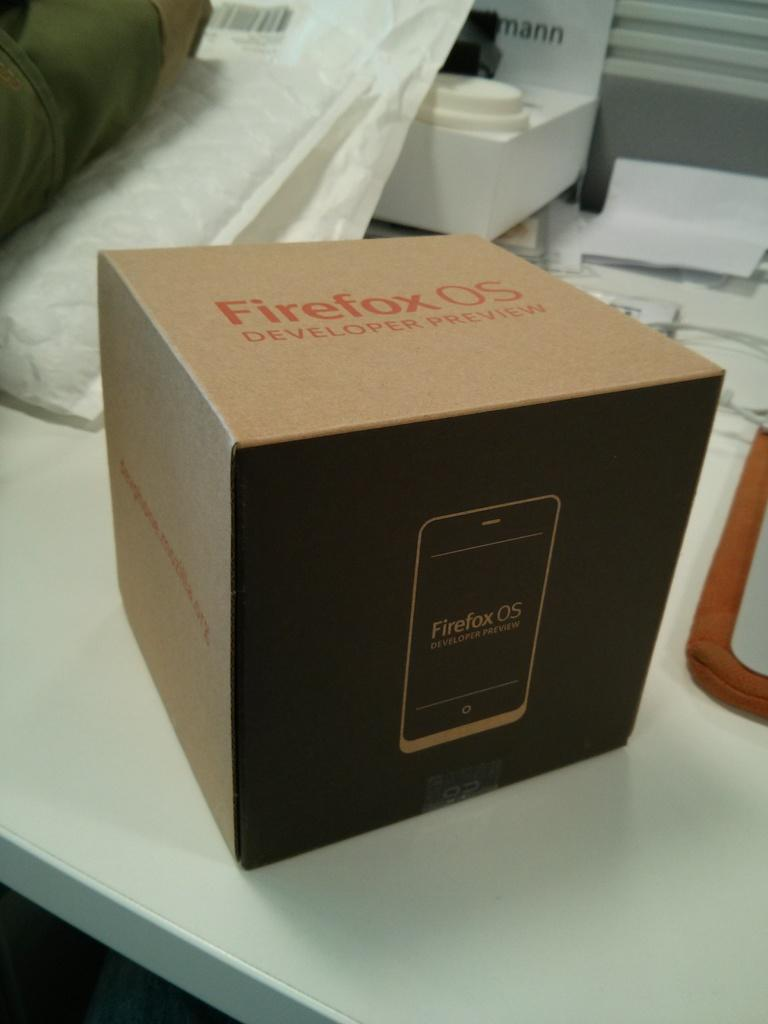<image>
Summarize the visual content of the image. a box for Firefox OS Eveloper Preview on a table 